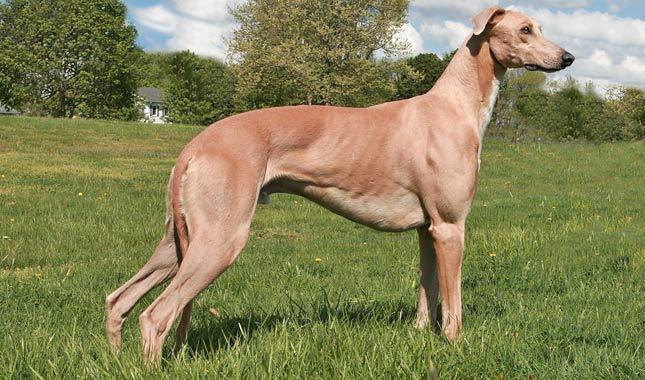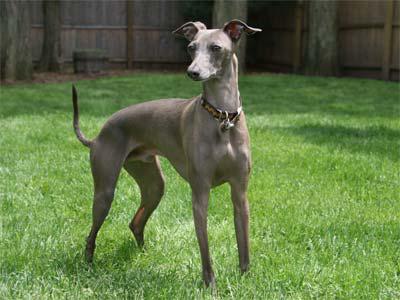The first image is the image on the left, the second image is the image on the right. For the images shown, is this caption "A hound wears a turtle-neck wrap in one image, and the other image shows a hound wearing a dog collar." true? Answer yes or no. No. The first image is the image on the left, the second image is the image on the right. For the images shown, is this caption "At least one of the dogs in the image on the left is standing on all four legs." true? Answer yes or no. Yes. 